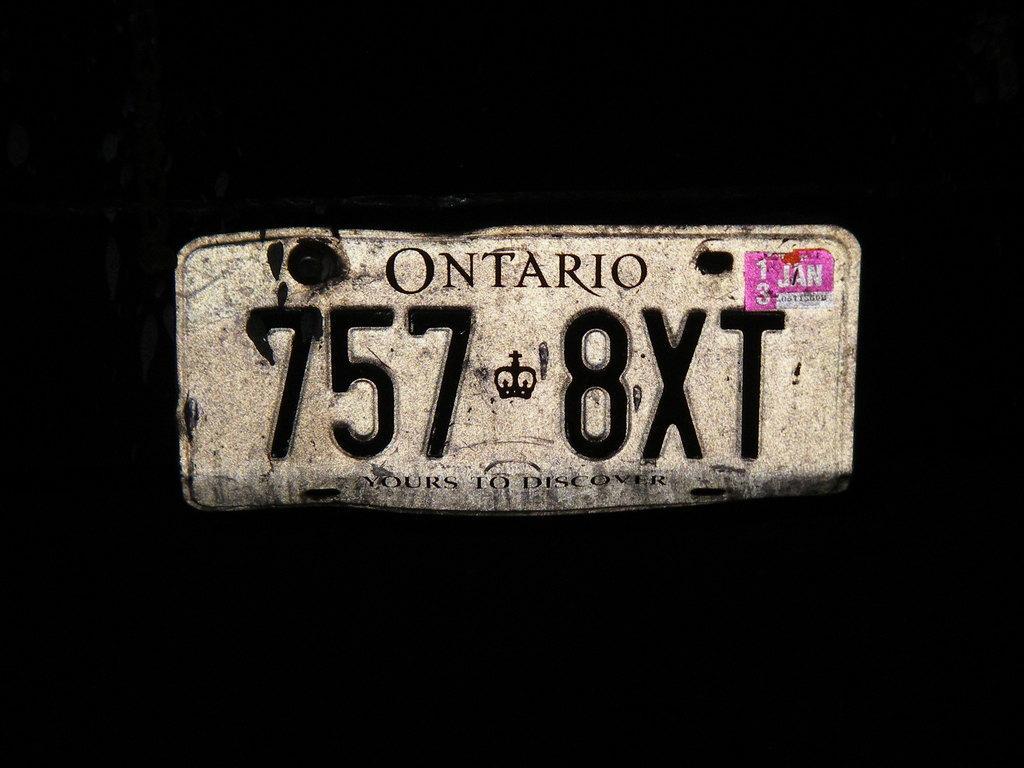Please provide a concise description of this image. In this image we can see a board with some text. The background of the image is black in color. 